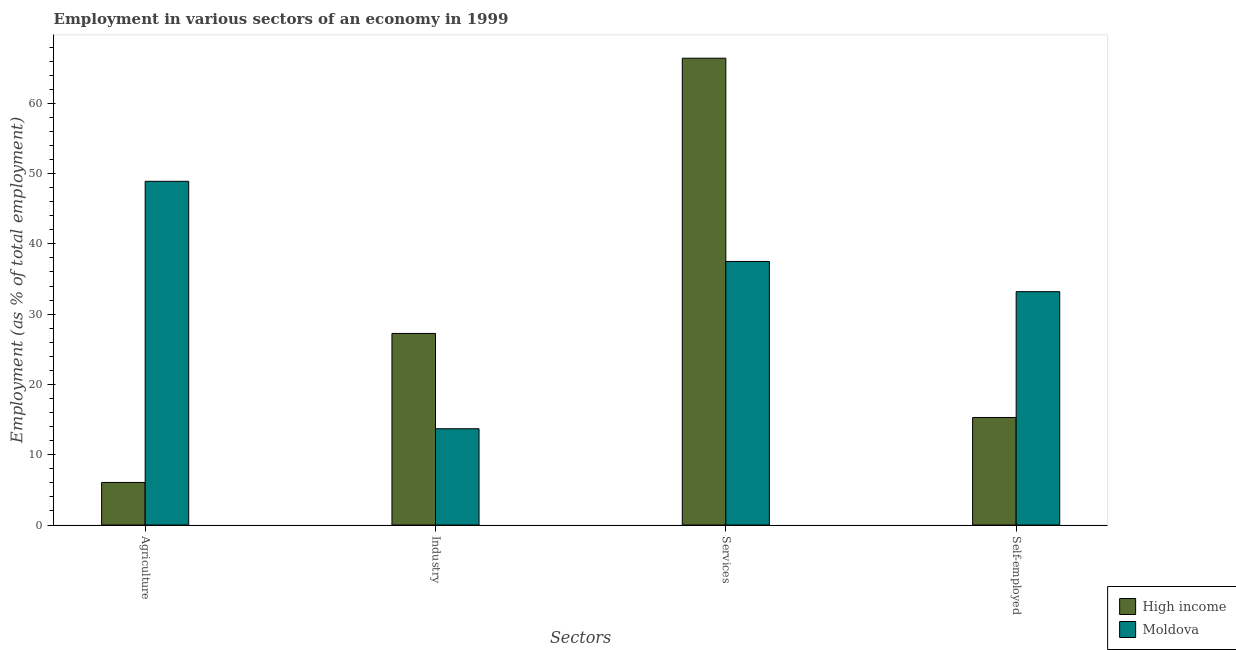How many groups of bars are there?
Ensure brevity in your answer.  4. Are the number of bars per tick equal to the number of legend labels?
Offer a very short reply. Yes. How many bars are there on the 4th tick from the left?
Provide a succinct answer. 2. What is the label of the 2nd group of bars from the left?
Your response must be concise. Industry. What is the percentage of self employed workers in Moldova?
Make the answer very short. 33.2. Across all countries, what is the maximum percentage of workers in industry?
Your answer should be very brief. 27.26. Across all countries, what is the minimum percentage of self employed workers?
Make the answer very short. 15.3. In which country was the percentage of self employed workers maximum?
Give a very brief answer. Moldova. In which country was the percentage of workers in industry minimum?
Keep it short and to the point. Moldova. What is the total percentage of self employed workers in the graph?
Ensure brevity in your answer.  48.5. What is the difference between the percentage of self employed workers in High income and that in Moldova?
Provide a succinct answer. -17.9. What is the difference between the percentage of workers in services in Moldova and the percentage of workers in agriculture in High income?
Keep it short and to the point. 31.44. What is the average percentage of workers in industry per country?
Give a very brief answer. 20.48. What is the difference between the percentage of workers in industry and percentage of workers in services in Moldova?
Offer a terse response. -23.8. In how many countries, is the percentage of workers in agriculture greater than 24 %?
Make the answer very short. 1. What is the ratio of the percentage of workers in industry in Moldova to that in High income?
Keep it short and to the point. 0.5. Is the percentage of workers in agriculture in High income less than that in Moldova?
Provide a succinct answer. Yes. What is the difference between the highest and the second highest percentage of workers in industry?
Offer a very short reply. 13.56. What is the difference between the highest and the lowest percentage of workers in industry?
Provide a succinct answer. 13.56. What does the 2nd bar from the left in Self-employed represents?
Keep it short and to the point. Moldova. What does the 1st bar from the right in Agriculture represents?
Ensure brevity in your answer.  Moldova. Is it the case that in every country, the sum of the percentage of workers in agriculture and percentage of workers in industry is greater than the percentage of workers in services?
Your answer should be compact. No. How many bars are there?
Provide a short and direct response. 8. Are all the bars in the graph horizontal?
Keep it short and to the point. No. How many legend labels are there?
Your answer should be compact. 2. What is the title of the graph?
Offer a very short reply. Employment in various sectors of an economy in 1999. What is the label or title of the X-axis?
Your answer should be very brief. Sectors. What is the label or title of the Y-axis?
Ensure brevity in your answer.  Employment (as % of total employment). What is the Employment (as % of total employment) of High income in Agriculture?
Keep it short and to the point. 6.06. What is the Employment (as % of total employment) in Moldova in Agriculture?
Offer a very short reply. 48.9. What is the Employment (as % of total employment) of High income in Industry?
Provide a short and direct response. 27.26. What is the Employment (as % of total employment) in Moldova in Industry?
Provide a short and direct response. 13.7. What is the Employment (as % of total employment) of High income in Services?
Ensure brevity in your answer.  66.41. What is the Employment (as % of total employment) of Moldova in Services?
Offer a very short reply. 37.5. What is the Employment (as % of total employment) in High income in Self-employed?
Keep it short and to the point. 15.3. What is the Employment (as % of total employment) in Moldova in Self-employed?
Your response must be concise. 33.2. Across all Sectors, what is the maximum Employment (as % of total employment) in High income?
Give a very brief answer. 66.41. Across all Sectors, what is the maximum Employment (as % of total employment) of Moldova?
Provide a succinct answer. 48.9. Across all Sectors, what is the minimum Employment (as % of total employment) in High income?
Provide a short and direct response. 6.06. Across all Sectors, what is the minimum Employment (as % of total employment) of Moldova?
Ensure brevity in your answer.  13.7. What is the total Employment (as % of total employment) of High income in the graph?
Your response must be concise. 115.03. What is the total Employment (as % of total employment) of Moldova in the graph?
Give a very brief answer. 133.3. What is the difference between the Employment (as % of total employment) of High income in Agriculture and that in Industry?
Your response must be concise. -21.2. What is the difference between the Employment (as % of total employment) of Moldova in Agriculture and that in Industry?
Give a very brief answer. 35.2. What is the difference between the Employment (as % of total employment) in High income in Agriculture and that in Services?
Your answer should be very brief. -60.35. What is the difference between the Employment (as % of total employment) in Moldova in Agriculture and that in Services?
Ensure brevity in your answer.  11.4. What is the difference between the Employment (as % of total employment) in High income in Agriculture and that in Self-employed?
Keep it short and to the point. -9.24. What is the difference between the Employment (as % of total employment) in High income in Industry and that in Services?
Keep it short and to the point. -39.15. What is the difference between the Employment (as % of total employment) in Moldova in Industry and that in Services?
Give a very brief answer. -23.8. What is the difference between the Employment (as % of total employment) of High income in Industry and that in Self-employed?
Your response must be concise. 11.96. What is the difference between the Employment (as % of total employment) in Moldova in Industry and that in Self-employed?
Give a very brief answer. -19.5. What is the difference between the Employment (as % of total employment) in High income in Services and that in Self-employed?
Provide a short and direct response. 51.11. What is the difference between the Employment (as % of total employment) in Moldova in Services and that in Self-employed?
Offer a terse response. 4.3. What is the difference between the Employment (as % of total employment) in High income in Agriculture and the Employment (as % of total employment) in Moldova in Industry?
Offer a terse response. -7.64. What is the difference between the Employment (as % of total employment) of High income in Agriculture and the Employment (as % of total employment) of Moldova in Services?
Offer a terse response. -31.44. What is the difference between the Employment (as % of total employment) of High income in Agriculture and the Employment (as % of total employment) of Moldova in Self-employed?
Provide a short and direct response. -27.14. What is the difference between the Employment (as % of total employment) in High income in Industry and the Employment (as % of total employment) in Moldova in Services?
Make the answer very short. -10.24. What is the difference between the Employment (as % of total employment) in High income in Industry and the Employment (as % of total employment) in Moldova in Self-employed?
Make the answer very short. -5.94. What is the difference between the Employment (as % of total employment) of High income in Services and the Employment (as % of total employment) of Moldova in Self-employed?
Offer a very short reply. 33.21. What is the average Employment (as % of total employment) of High income per Sectors?
Keep it short and to the point. 28.76. What is the average Employment (as % of total employment) of Moldova per Sectors?
Keep it short and to the point. 33.33. What is the difference between the Employment (as % of total employment) in High income and Employment (as % of total employment) in Moldova in Agriculture?
Offer a terse response. -42.84. What is the difference between the Employment (as % of total employment) of High income and Employment (as % of total employment) of Moldova in Industry?
Your response must be concise. 13.56. What is the difference between the Employment (as % of total employment) in High income and Employment (as % of total employment) in Moldova in Services?
Provide a short and direct response. 28.91. What is the difference between the Employment (as % of total employment) of High income and Employment (as % of total employment) of Moldova in Self-employed?
Your answer should be compact. -17.9. What is the ratio of the Employment (as % of total employment) of High income in Agriculture to that in Industry?
Keep it short and to the point. 0.22. What is the ratio of the Employment (as % of total employment) in Moldova in Agriculture to that in Industry?
Offer a very short reply. 3.57. What is the ratio of the Employment (as % of total employment) in High income in Agriculture to that in Services?
Your answer should be compact. 0.09. What is the ratio of the Employment (as % of total employment) in Moldova in Agriculture to that in Services?
Your answer should be compact. 1.3. What is the ratio of the Employment (as % of total employment) in High income in Agriculture to that in Self-employed?
Offer a terse response. 0.4. What is the ratio of the Employment (as % of total employment) in Moldova in Agriculture to that in Self-employed?
Your response must be concise. 1.47. What is the ratio of the Employment (as % of total employment) of High income in Industry to that in Services?
Your answer should be compact. 0.41. What is the ratio of the Employment (as % of total employment) in Moldova in Industry to that in Services?
Your response must be concise. 0.37. What is the ratio of the Employment (as % of total employment) in High income in Industry to that in Self-employed?
Your answer should be compact. 1.78. What is the ratio of the Employment (as % of total employment) in Moldova in Industry to that in Self-employed?
Provide a succinct answer. 0.41. What is the ratio of the Employment (as % of total employment) in High income in Services to that in Self-employed?
Provide a short and direct response. 4.34. What is the ratio of the Employment (as % of total employment) in Moldova in Services to that in Self-employed?
Your answer should be compact. 1.13. What is the difference between the highest and the second highest Employment (as % of total employment) in High income?
Provide a succinct answer. 39.15. What is the difference between the highest and the lowest Employment (as % of total employment) of High income?
Make the answer very short. 60.35. What is the difference between the highest and the lowest Employment (as % of total employment) of Moldova?
Your response must be concise. 35.2. 